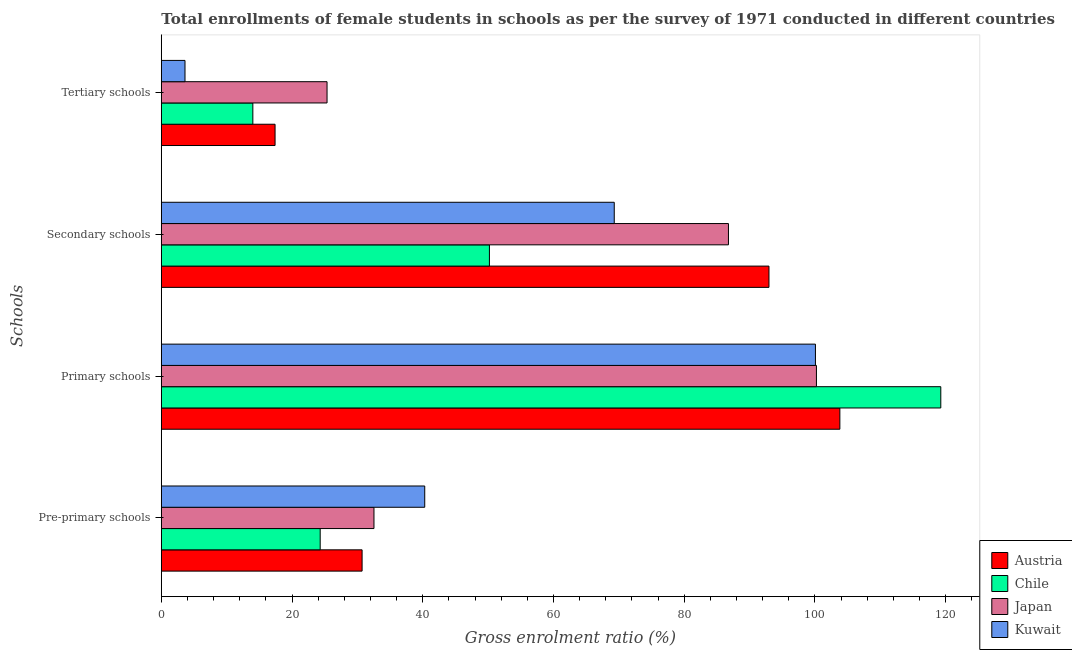How many different coloured bars are there?
Give a very brief answer. 4. How many bars are there on the 4th tick from the top?
Offer a terse response. 4. How many bars are there on the 3rd tick from the bottom?
Offer a very short reply. 4. What is the label of the 4th group of bars from the top?
Your answer should be very brief. Pre-primary schools. What is the gross enrolment ratio(female) in secondary schools in Chile?
Offer a very short reply. 50.19. Across all countries, what is the maximum gross enrolment ratio(female) in secondary schools?
Give a very brief answer. 92.96. Across all countries, what is the minimum gross enrolment ratio(female) in tertiary schools?
Keep it short and to the point. 3.62. In which country was the gross enrolment ratio(female) in primary schools minimum?
Provide a short and direct response. Kuwait. What is the total gross enrolment ratio(female) in primary schools in the graph?
Make the answer very short. 423.35. What is the difference between the gross enrolment ratio(female) in pre-primary schools in Kuwait and that in Austria?
Offer a very short reply. 9.58. What is the difference between the gross enrolment ratio(female) in primary schools in Japan and the gross enrolment ratio(female) in secondary schools in Kuwait?
Give a very brief answer. 30.93. What is the average gross enrolment ratio(female) in secondary schools per country?
Your answer should be compact. 74.8. What is the difference between the gross enrolment ratio(female) in primary schools and gross enrolment ratio(female) in tertiary schools in Kuwait?
Your answer should be very brief. 96.45. What is the ratio of the gross enrolment ratio(female) in pre-primary schools in Chile to that in Kuwait?
Make the answer very short. 0.6. What is the difference between the highest and the second highest gross enrolment ratio(female) in tertiary schools?
Give a very brief answer. 7.95. What is the difference between the highest and the lowest gross enrolment ratio(female) in secondary schools?
Make the answer very short. 42.77. In how many countries, is the gross enrolment ratio(female) in primary schools greater than the average gross enrolment ratio(female) in primary schools taken over all countries?
Your answer should be very brief. 1. Is it the case that in every country, the sum of the gross enrolment ratio(female) in secondary schools and gross enrolment ratio(female) in primary schools is greater than the sum of gross enrolment ratio(female) in pre-primary schools and gross enrolment ratio(female) in tertiary schools?
Your answer should be compact. Yes. What does the 1st bar from the top in Tertiary schools represents?
Ensure brevity in your answer.  Kuwait. How many countries are there in the graph?
Provide a short and direct response. 4. Does the graph contain grids?
Your answer should be very brief. No. Where does the legend appear in the graph?
Give a very brief answer. Bottom right. How many legend labels are there?
Provide a short and direct response. 4. How are the legend labels stacked?
Make the answer very short. Vertical. What is the title of the graph?
Provide a short and direct response. Total enrollments of female students in schools as per the survey of 1971 conducted in different countries. Does "Chile" appear as one of the legend labels in the graph?
Give a very brief answer. Yes. What is the label or title of the Y-axis?
Offer a very short reply. Schools. What is the Gross enrolment ratio (%) of Austria in Pre-primary schools?
Make the answer very short. 30.72. What is the Gross enrolment ratio (%) of Chile in Pre-primary schools?
Ensure brevity in your answer.  24.3. What is the Gross enrolment ratio (%) of Japan in Pre-primary schools?
Your answer should be compact. 32.53. What is the Gross enrolment ratio (%) in Kuwait in Pre-primary schools?
Give a very brief answer. 40.3. What is the Gross enrolment ratio (%) in Austria in Primary schools?
Offer a terse response. 103.81. What is the Gross enrolment ratio (%) in Chile in Primary schools?
Offer a terse response. 119.25. What is the Gross enrolment ratio (%) in Japan in Primary schools?
Offer a terse response. 100.22. What is the Gross enrolment ratio (%) in Kuwait in Primary schools?
Make the answer very short. 100.07. What is the Gross enrolment ratio (%) in Austria in Secondary schools?
Provide a succinct answer. 92.96. What is the Gross enrolment ratio (%) in Chile in Secondary schools?
Ensure brevity in your answer.  50.19. What is the Gross enrolment ratio (%) of Japan in Secondary schools?
Your answer should be compact. 86.76. What is the Gross enrolment ratio (%) of Kuwait in Secondary schools?
Your answer should be very brief. 69.29. What is the Gross enrolment ratio (%) of Austria in Tertiary schools?
Offer a terse response. 17.4. What is the Gross enrolment ratio (%) of Chile in Tertiary schools?
Ensure brevity in your answer.  14. What is the Gross enrolment ratio (%) in Japan in Tertiary schools?
Give a very brief answer. 25.35. What is the Gross enrolment ratio (%) in Kuwait in Tertiary schools?
Your answer should be very brief. 3.62. Across all Schools, what is the maximum Gross enrolment ratio (%) of Austria?
Offer a terse response. 103.81. Across all Schools, what is the maximum Gross enrolment ratio (%) of Chile?
Your response must be concise. 119.25. Across all Schools, what is the maximum Gross enrolment ratio (%) of Japan?
Make the answer very short. 100.22. Across all Schools, what is the maximum Gross enrolment ratio (%) of Kuwait?
Make the answer very short. 100.07. Across all Schools, what is the minimum Gross enrolment ratio (%) of Austria?
Offer a terse response. 17.4. Across all Schools, what is the minimum Gross enrolment ratio (%) in Chile?
Provide a succinct answer. 14. Across all Schools, what is the minimum Gross enrolment ratio (%) in Japan?
Your response must be concise. 25.35. Across all Schools, what is the minimum Gross enrolment ratio (%) in Kuwait?
Offer a very short reply. 3.62. What is the total Gross enrolment ratio (%) in Austria in the graph?
Give a very brief answer. 244.88. What is the total Gross enrolment ratio (%) in Chile in the graph?
Your response must be concise. 207.75. What is the total Gross enrolment ratio (%) in Japan in the graph?
Keep it short and to the point. 244.87. What is the total Gross enrolment ratio (%) of Kuwait in the graph?
Make the answer very short. 213.28. What is the difference between the Gross enrolment ratio (%) of Austria in Pre-primary schools and that in Primary schools?
Your response must be concise. -73.09. What is the difference between the Gross enrolment ratio (%) of Chile in Pre-primary schools and that in Primary schools?
Offer a terse response. -94.94. What is the difference between the Gross enrolment ratio (%) of Japan in Pre-primary schools and that in Primary schools?
Your answer should be very brief. -67.69. What is the difference between the Gross enrolment ratio (%) in Kuwait in Pre-primary schools and that in Primary schools?
Ensure brevity in your answer.  -59.77. What is the difference between the Gross enrolment ratio (%) of Austria in Pre-primary schools and that in Secondary schools?
Provide a succinct answer. -62.25. What is the difference between the Gross enrolment ratio (%) of Chile in Pre-primary schools and that in Secondary schools?
Make the answer very short. -25.89. What is the difference between the Gross enrolment ratio (%) in Japan in Pre-primary schools and that in Secondary schools?
Your response must be concise. -54.23. What is the difference between the Gross enrolment ratio (%) of Kuwait in Pre-primary schools and that in Secondary schools?
Offer a very short reply. -28.99. What is the difference between the Gross enrolment ratio (%) in Austria in Pre-primary schools and that in Tertiary schools?
Give a very brief answer. 13.31. What is the difference between the Gross enrolment ratio (%) of Chile in Pre-primary schools and that in Tertiary schools?
Your response must be concise. 10.3. What is the difference between the Gross enrolment ratio (%) in Japan in Pre-primary schools and that in Tertiary schools?
Your answer should be very brief. 7.18. What is the difference between the Gross enrolment ratio (%) in Kuwait in Pre-primary schools and that in Tertiary schools?
Give a very brief answer. 36.68. What is the difference between the Gross enrolment ratio (%) in Austria in Primary schools and that in Secondary schools?
Offer a terse response. 10.85. What is the difference between the Gross enrolment ratio (%) in Chile in Primary schools and that in Secondary schools?
Your response must be concise. 69.05. What is the difference between the Gross enrolment ratio (%) of Japan in Primary schools and that in Secondary schools?
Make the answer very short. 13.46. What is the difference between the Gross enrolment ratio (%) of Kuwait in Primary schools and that in Secondary schools?
Keep it short and to the point. 30.78. What is the difference between the Gross enrolment ratio (%) of Austria in Primary schools and that in Tertiary schools?
Your answer should be very brief. 86.41. What is the difference between the Gross enrolment ratio (%) of Chile in Primary schools and that in Tertiary schools?
Provide a short and direct response. 105.25. What is the difference between the Gross enrolment ratio (%) in Japan in Primary schools and that in Tertiary schools?
Give a very brief answer. 74.87. What is the difference between the Gross enrolment ratio (%) in Kuwait in Primary schools and that in Tertiary schools?
Make the answer very short. 96.45. What is the difference between the Gross enrolment ratio (%) in Austria in Secondary schools and that in Tertiary schools?
Offer a terse response. 75.56. What is the difference between the Gross enrolment ratio (%) in Chile in Secondary schools and that in Tertiary schools?
Your answer should be compact. 36.19. What is the difference between the Gross enrolment ratio (%) of Japan in Secondary schools and that in Tertiary schools?
Ensure brevity in your answer.  61.41. What is the difference between the Gross enrolment ratio (%) in Kuwait in Secondary schools and that in Tertiary schools?
Make the answer very short. 65.67. What is the difference between the Gross enrolment ratio (%) in Austria in Pre-primary schools and the Gross enrolment ratio (%) in Chile in Primary schools?
Your response must be concise. -88.53. What is the difference between the Gross enrolment ratio (%) of Austria in Pre-primary schools and the Gross enrolment ratio (%) of Japan in Primary schools?
Provide a succinct answer. -69.51. What is the difference between the Gross enrolment ratio (%) of Austria in Pre-primary schools and the Gross enrolment ratio (%) of Kuwait in Primary schools?
Your response must be concise. -69.36. What is the difference between the Gross enrolment ratio (%) of Chile in Pre-primary schools and the Gross enrolment ratio (%) of Japan in Primary schools?
Your response must be concise. -75.92. What is the difference between the Gross enrolment ratio (%) in Chile in Pre-primary schools and the Gross enrolment ratio (%) in Kuwait in Primary schools?
Keep it short and to the point. -75.77. What is the difference between the Gross enrolment ratio (%) in Japan in Pre-primary schools and the Gross enrolment ratio (%) in Kuwait in Primary schools?
Keep it short and to the point. -67.54. What is the difference between the Gross enrolment ratio (%) in Austria in Pre-primary schools and the Gross enrolment ratio (%) in Chile in Secondary schools?
Give a very brief answer. -19.48. What is the difference between the Gross enrolment ratio (%) in Austria in Pre-primary schools and the Gross enrolment ratio (%) in Japan in Secondary schools?
Your answer should be very brief. -56.05. What is the difference between the Gross enrolment ratio (%) in Austria in Pre-primary schools and the Gross enrolment ratio (%) in Kuwait in Secondary schools?
Keep it short and to the point. -38.58. What is the difference between the Gross enrolment ratio (%) of Chile in Pre-primary schools and the Gross enrolment ratio (%) of Japan in Secondary schools?
Your answer should be compact. -62.46. What is the difference between the Gross enrolment ratio (%) in Chile in Pre-primary schools and the Gross enrolment ratio (%) in Kuwait in Secondary schools?
Keep it short and to the point. -44.99. What is the difference between the Gross enrolment ratio (%) in Japan in Pre-primary schools and the Gross enrolment ratio (%) in Kuwait in Secondary schools?
Give a very brief answer. -36.76. What is the difference between the Gross enrolment ratio (%) in Austria in Pre-primary schools and the Gross enrolment ratio (%) in Chile in Tertiary schools?
Offer a terse response. 16.71. What is the difference between the Gross enrolment ratio (%) in Austria in Pre-primary schools and the Gross enrolment ratio (%) in Japan in Tertiary schools?
Keep it short and to the point. 5.36. What is the difference between the Gross enrolment ratio (%) of Austria in Pre-primary schools and the Gross enrolment ratio (%) of Kuwait in Tertiary schools?
Your answer should be compact. 27.09. What is the difference between the Gross enrolment ratio (%) of Chile in Pre-primary schools and the Gross enrolment ratio (%) of Japan in Tertiary schools?
Give a very brief answer. -1.05. What is the difference between the Gross enrolment ratio (%) in Chile in Pre-primary schools and the Gross enrolment ratio (%) in Kuwait in Tertiary schools?
Make the answer very short. 20.68. What is the difference between the Gross enrolment ratio (%) in Japan in Pre-primary schools and the Gross enrolment ratio (%) in Kuwait in Tertiary schools?
Your answer should be compact. 28.91. What is the difference between the Gross enrolment ratio (%) in Austria in Primary schools and the Gross enrolment ratio (%) in Chile in Secondary schools?
Make the answer very short. 53.61. What is the difference between the Gross enrolment ratio (%) of Austria in Primary schools and the Gross enrolment ratio (%) of Japan in Secondary schools?
Offer a very short reply. 17.04. What is the difference between the Gross enrolment ratio (%) in Austria in Primary schools and the Gross enrolment ratio (%) in Kuwait in Secondary schools?
Give a very brief answer. 34.52. What is the difference between the Gross enrolment ratio (%) in Chile in Primary schools and the Gross enrolment ratio (%) in Japan in Secondary schools?
Give a very brief answer. 32.48. What is the difference between the Gross enrolment ratio (%) of Chile in Primary schools and the Gross enrolment ratio (%) of Kuwait in Secondary schools?
Your response must be concise. 49.96. What is the difference between the Gross enrolment ratio (%) in Japan in Primary schools and the Gross enrolment ratio (%) in Kuwait in Secondary schools?
Offer a very short reply. 30.93. What is the difference between the Gross enrolment ratio (%) in Austria in Primary schools and the Gross enrolment ratio (%) in Chile in Tertiary schools?
Give a very brief answer. 89.8. What is the difference between the Gross enrolment ratio (%) of Austria in Primary schools and the Gross enrolment ratio (%) of Japan in Tertiary schools?
Offer a very short reply. 78.45. What is the difference between the Gross enrolment ratio (%) in Austria in Primary schools and the Gross enrolment ratio (%) in Kuwait in Tertiary schools?
Keep it short and to the point. 100.18. What is the difference between the Gross enrolment ratio (%) of Chile in Primary schools and the Gross enrolment ratio (%) of Japan in Tertiary schools?
Your answer should be very brief. 93.89. What is the difference between the Gross enrolment ratio (%) of Chile in Primary schools and the Gross enrolment ratio (%) of Kuwait in Tertiary schools?
Provide a succinct answer. 115.63. What is the difference between the Gross enrolment ratio (%) in Japan in Primary schools and the Gross enrolment ratio (%) in Kuwait in Tertiary schools?
Offer a terse response. 96.6. What is the difference between the Gross enrolment ratio (%) in Austria in Secondary schools and the Gross enrolment ratio (%) in Chile in Tertiary schools?
Your answer should be very brief. 78.96. What is the difference between the Gross enrolment ratio (%) of Austria in Secondary schools and the Gross enrolment ratio (%) of Japan in Tertiary schools?
Ensure brevity in your answer.  67.61. What is the difference between the Gross enrolment ratio (%) in Austria in Secondary schools and the Gross enrolment ratio (%) in Kuwait in Tertiary schools?
Provide a succinct answer. 89.34. What is the difference between the Gross enrolment ratio (%) of Chile in Secondary schools and the Gross enrolment ratio (%) of Japan in Tertiary schools?
Give a very brief answer. 24.84. What is the difference between the Gross enrolment ratio (%) in Chile in Secondary schools and the Gross enrolment ratio (%) in Kuwait in Tertiary schools?
Give a very brief answer. 46.57. What is the difference between the Gross enrolment ratio (%) in Japan in Secondary schools and the Gross enrolment ratio (%) in Kuwait in Tertiary schools?
Your answer should be very brief. 83.14. What is the average Gross enrolment ratio (%) of Austria per Schools?
Provide a succinct answer. 61.22. What is the average Gross enrolment ratio (%) of Chile per Schools?
Your answer should be compact. 51.94. What is the average Gross enrolment ratio (%) of Japan per Schools?
Your answer should be compact. 61.22. What is the average Gross enrolment ratio (%) in Kuwait per Schools?
Your answer should be very brief. 53.32. What is the difference between the Gross enrolment ratio (%) in Austria and Gross enrolment ratio (%) in Chile in Pre-primary schools?
Ensure brevity in your answer.  6.41. What is the difference between the Gross enrolment ratio (%) in Austria and Gross enrolment ratio (%) in Japan in Pre-primary schools?
Make the answer very short. -1.82. What is the difference between the Gross enrolment ratio (%) in Austria and Gross enrolment ratio (%) in Kuwait in Pre-primary schools?
Your answer should be very brief. -9.58. What is the difference between the Gross enrolment ratio (%) of Chile and Gross enrolment ratio (%) of Japan in Pre-primary schools?
Keep it short and to the point. -8.23. What is the difference between the Gross enrolment ratio (%) of Chile and Gross enrolment ratio (%) of Kuwait in Pre-primary schools?
Offer a terse response. -15.99. What is the difference between the Gross enrolment ratio (%) of Japan and Gross enrolment ratio (%) of Kuwait in Pre-primary schools?
Offer a terse response. -7.76. What is the difference between the Gross enrolment ratio (%) in Austria and Gross enrolment ratio (%) in Chile in Primary schools?
Offer a very short reply. -15.44. What is the difference between the Gross enrolment ratio (%) of Austria and Gross enrolment ratio (%) of Japan in Primary schools?
Your answer should be compact. 3.58. What is the difference between the Gross enrolment ratio (%) of Austria and Gross enrolment ratio (%) of Kuwait in Primary schools?
Offer a terse response. 3.74. What is the difference between the Gross enrolment ratio (%) of Chile and Gross enrolment ratio (%) of Japan in Primary schools?
Offer a terse response. 19.03. What is the difference between the Gross enrolment ratio (%) of Chile and Gross enrolment ratio (%) of Kuwait in Primary schools?
Make the answer very short. 19.18. What is the difference between the Gross enrolment ratio (%) of Japan and Gross enrolment ratio (%) of Kuwait in Primary schools?
Give a very brief answer. 0.15. What is the difference between the Gross enrolment ratio (%) of Austria and Gross enrolment ratio (%) of Chile in Secondary schools?
Offer a very short reply. 42.77. What is the difference between the Gross enrolment ratio (%) in Austria and Gross enrolment ratio (%) in Japan in Secondary schools?
Offer a very short reply. 6.2. What is the difference between the Gross enrolment ratio (%) of Austria and Gross enrolment ratio (%) of Kuwait in Secondary schools?
Ensure brevity in your answer.  23.67. What is the difference between the Gross enrolment ratio (%) of Chile and Gross enrolment ratio (%) of Japan in Secondary schools?
Ensure brevity in your answer.  -36.57. What is the difference between the Gross enrolment ratio (%) in Chile and Gross enrolment ratio (%) in Kuwait in Secondary schools?
Provide a short and direct response. -19.1. What is the difference between the Gross enrolment ratio (%) of Japan and Gross enrolment ratio (%) of Kuwait in Secondary schools?
Your response must be concise. 17.47. What is the difference between the Gross enrolment ratio (%) in Austria and Gross enrolment ratio (%) in Chile in Tertiary schools?
Provide a short and direct response. 3.4. What is the difference between the Gross enrolment ratio (%) of Austria and Gross enrolment ratio (%) of Japan in Tertiary schools?
Provide a succinct answer. -7.95. What is the difference between the Gross enrolment ratio (%) in Austria and Gross enrolment ratio (%) in Kuwait in Tertiary schools?
Give a very brief answer. 13.78. What is the difference between the Gross enrolment ratio (%) of Chile and Gross enrolment ratio (%) of Japan in Tertiary schools?
Give a very brief answer. -11.35. What is the difference between the Gross enrolment ratio (%) in Chile and Gross enrolment ratio (%) in Kuwait in Tertiary schools?
Ensure brevity in your answer.  10.38. What is the difference between the Gross enrolment ratio (%) of Japan and Gross enrolment ratio (%) of Kuwait in Tertiary schools?
Provide a succinct answer. 21.73. What is the ratio of the Gross enrolment ratio (%) in Austria in Pre-primary schools to that in Primary schools?
Your answer should be very brief. 0.3. What is the ratio of the Gross enrolment ratio (%) in Chile in Pre-primary schools to that in Primary schools?
Give a very brief answer. 0.2. What is the ratio of the Gross enrolment ratio (%) in Japan in Pre-primary schools to that in Primary schools?
Your answer should be compact. 0.32. What is the ratio of the Gross enrolment ratio (%) of Kuwait in Pre-primary schools to that in Primary schools?
Keep it short and to the point. 0.4. What is the ratio of the Gross enrolment ratio (%) in Austria in Pre-primary schools to that in Secondary schools?
Provide a succinct answer. 0.33. What is the ratio of the Gross enrolment ratio (%) in Chile in Pre-primary schools to that in Secondary schools?
Offer a very short reply. 0.48. What is the ratio of the Gross enrolment ratio (%) of Japan in Pre-primary schools to that in Secondary schools?
Offer a terse response. 0.38. What is the ratio of the Gross enrolment ratio (%) of Kuwait in Pre-primary schools to that in Secondary schools?
Make the answer very short. 0.58. What is the ratio of the Gross enrolment ratio (%) in Austria in Pre-primary schools to that in Tertiary schools?
Your answer should be very brief. 1.77. What is the ratio of the Gross enrolment ratio (%) of Chile in Pre-primary schools to that in Tertiary schools?
Ensure brevity in your answer.  1.74. What is the ratio of the Gross enrolment ratio (%) of Japan in Pre-primary schools to that in Tertiary schools?
Provide a short and direct response. 1.28. What is the ratio of the Gross enrolment ratio (%) of Kuwait in Pre-primary schools to that in Tertiary schools?
Offer a very short reply. 11.12. What is the ratio of the Gross enrolment ratio (%) of Austria in Primary schools to that in Secondary schools?
Your answer should be very brief. 1.12. What is the ratio of the Gross enrolment ratio (%) in Chile in Primary schools to that in Secondary schools?
Give a very brief answer. 2.38. What is the ratio of the Gross enrolment ratio (%) of Japan in Primary schools to that in Secondary schools?
Ensure brevity in your answer.  1.16. What is the ratio of the Gross enrolment ratio (%) in Kuwait in Primary schools to that in Secondary schools?
Provide a succinct answer. 1.44. What is the ratio of the Gross enrolment ratio (%) of Austria in Primary schools to that in Tertiary schools?
Ensure brevity in your answer.  5.97. What is the ratio of the Gross enrolment ratio (%) of Chile in Primary schools to that in Tertiary schools?
Offer a very short reply. 8.52. What is the ratio of the Gross enrolment ratio (%) of Japan in Primary schools to that in Tertiary schools?
Make the answer very short. 3.95. What is the ratio of the Gross enrolment ratio (%) in Kuwait in Primary schools to that in Tertiary schools?
Ensure brevity in your answer.  27.62. What is the ratio of the Gross enrolment ratio (%) of Austria in Secondary schools to that in Tertiary schools?
Your response must be concise. 5.34. What is the ratio of the Gross enrolment ratio (%) in Chile in Secondary schools to that in Tertiary schools?
Your answer should be compact. 3.58. What is the ratio of the Gross enrolment ratio (%) in Japan in Secondary schools to that in Tertiary schools?
Your answer should be compact. 3.42. What is the ratio of the Gross enrolment ratio (%) in Kuwait in Secondary schools to that in Tertiary schools?
Ensure brevity in your answer.  19.13. What is the difference between the highest and the second highest Gross enrolment ratio (%) in Austria?
Your answer should be very brief. 10.85. What is the difference between the highest and the second highest Gross enrolment ratio (%) of Chile?
Provide a succinct answer. 69.05. What is the difference between the highest and the second highest Gross enrolment ratio (%) of Japan?
Offer a very short reply. 13.46. What is the difference between the highest and the second highest Gross enrolment ratio (%) in Kuwait?
Your answer should be compact. 30.78. What is the difference between the highest and the lowest Gross enrolment ratio (%) in Austria?
Provide a short and direct response. 86.41. What is the difference between the highest and the lowest Gross enrolment ratio (%) in Chile?
Your answer should be very brief. 105.25. What is the difference between the highest and the lowest Gross enrolment ratio (%) of Japan?
Give a very brief answer. 74.87. What is the difference between the highest and the lowest Gross enrolment ratio (%) in Kuwait?
Give a very brief answer. 96.45. 